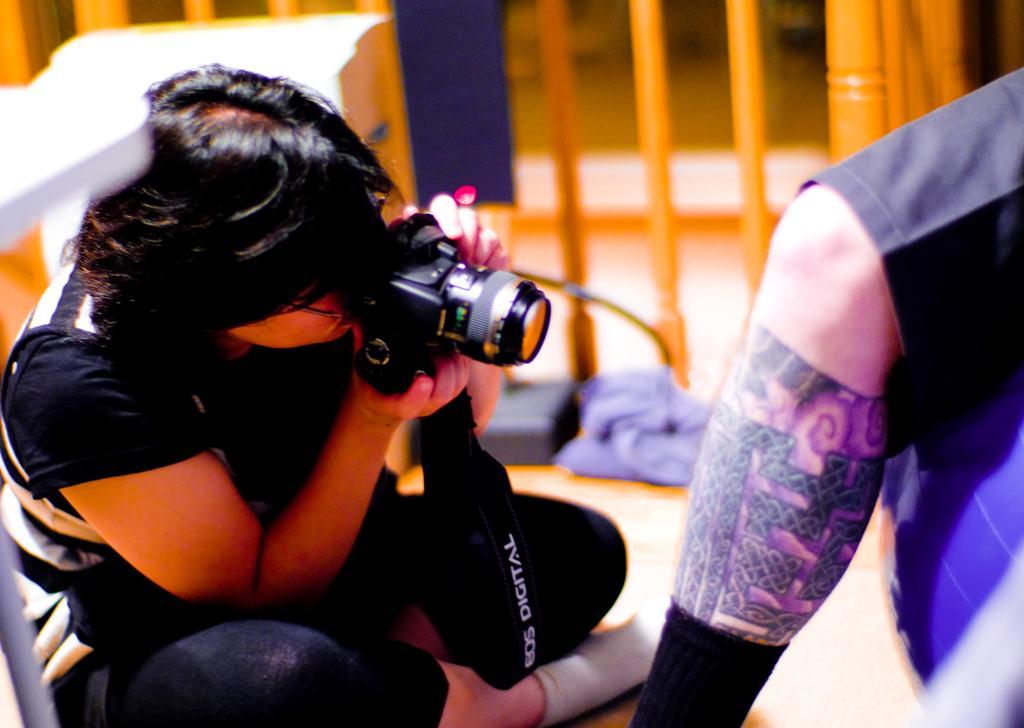Could you give a brief overview of what you see in this image? In this image i can see a person wearing a black dress and socks sitting on the floor and holding a camera. To the right of the image I can see a person's leg. In the background I can see few clothes and the floor. 